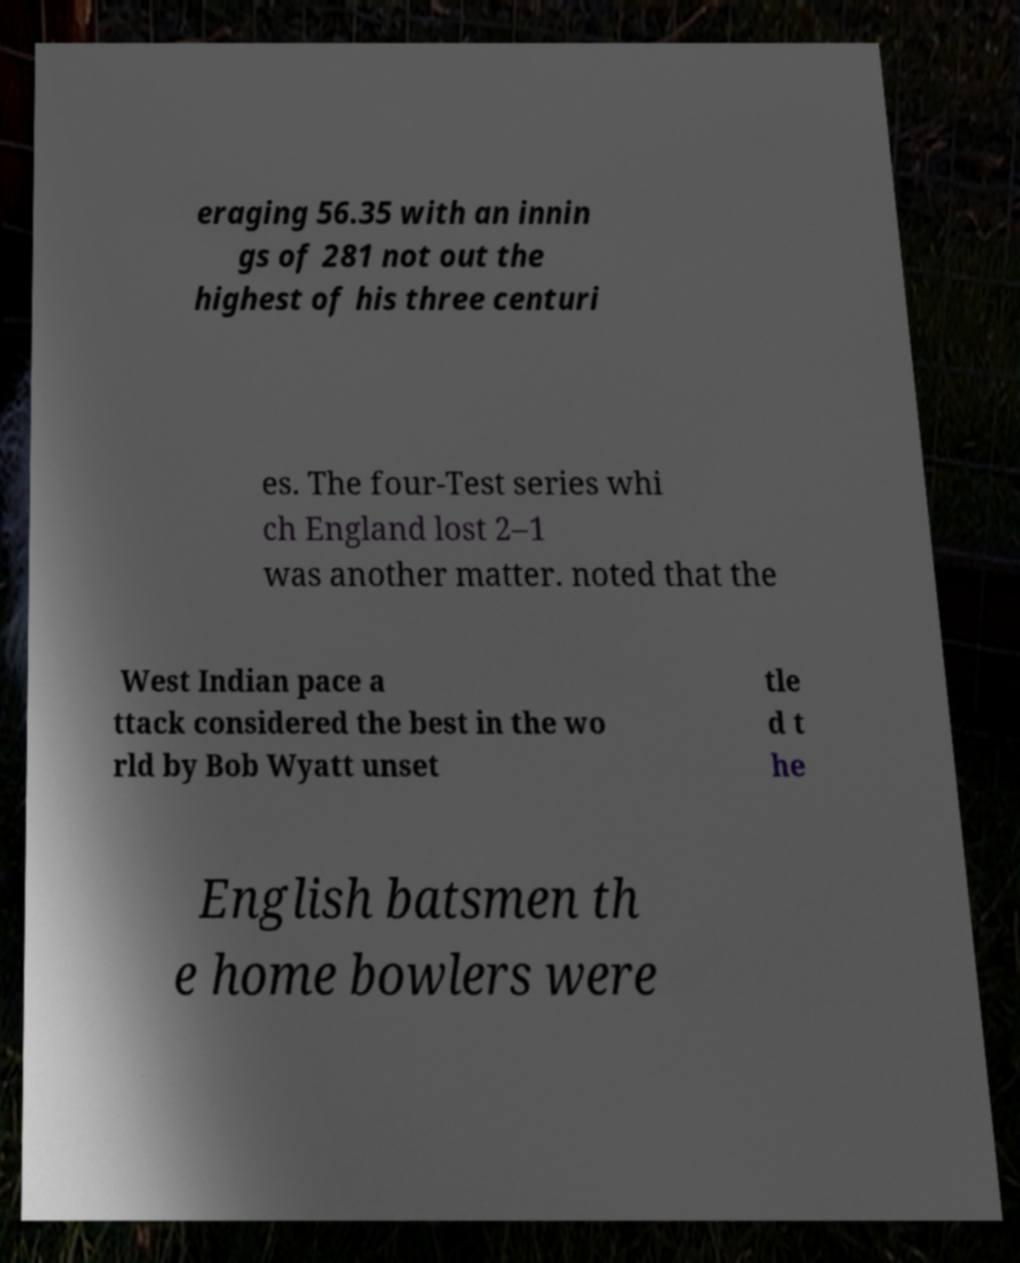Can you read and provide the text displayed in the image?This photo seems to have some interesting text. Can you extract and type it out for me? eraging 56.35 with an innin gs of 281 not out the highest of his three centuri es. The four-Test series whi ch England lost 2–1 was another matter. noted that the West Indian pace a ttack considered the best in the wo rld by Bob Wyatt unset tle d t he English batsmen th e home bowlers were 